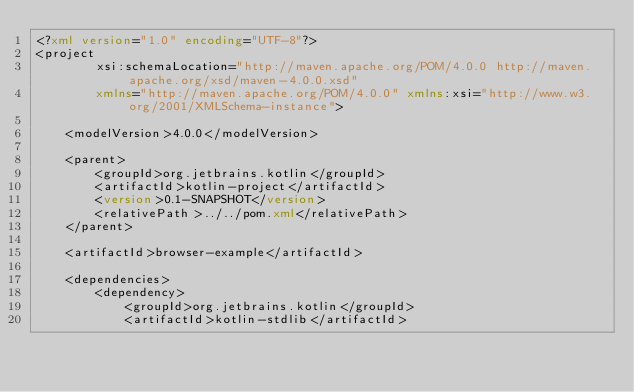<code> <loc_0><loc_0><loc_500><loc_500><_XML_><?xml version="1.0" encoding="UTF-8"?>
<project
        xsi:schemaLocation="http://maven.apache.org/POM/4.0.0 http://maven.apache.org/xsd/maven-4.0.0.xsd"
        xmlns="http://maven.apache.org/POM/4.0.0" xmlns:xsi="http://www.w3.org/2001/XMLSchema-instance">

    <modelVersion>4.0.0</modelVersion>

    <parent>
        <groupId>org.jetbrains.kotlin</groupId>
        <artifactId>kotlin-project</artifactId>
        <version>0.1-SNAPSHOT</version>
        <relativePath>../../pom.xml</relativePath>
    </parent>

    <artifactId>browser-example</artifactId>

    <dependencies>
        <dependency>
            <groupId>org.jetbrains.kotlin</groupId>
            <artifactId>kotlin-stdlib</artifactId></code> 